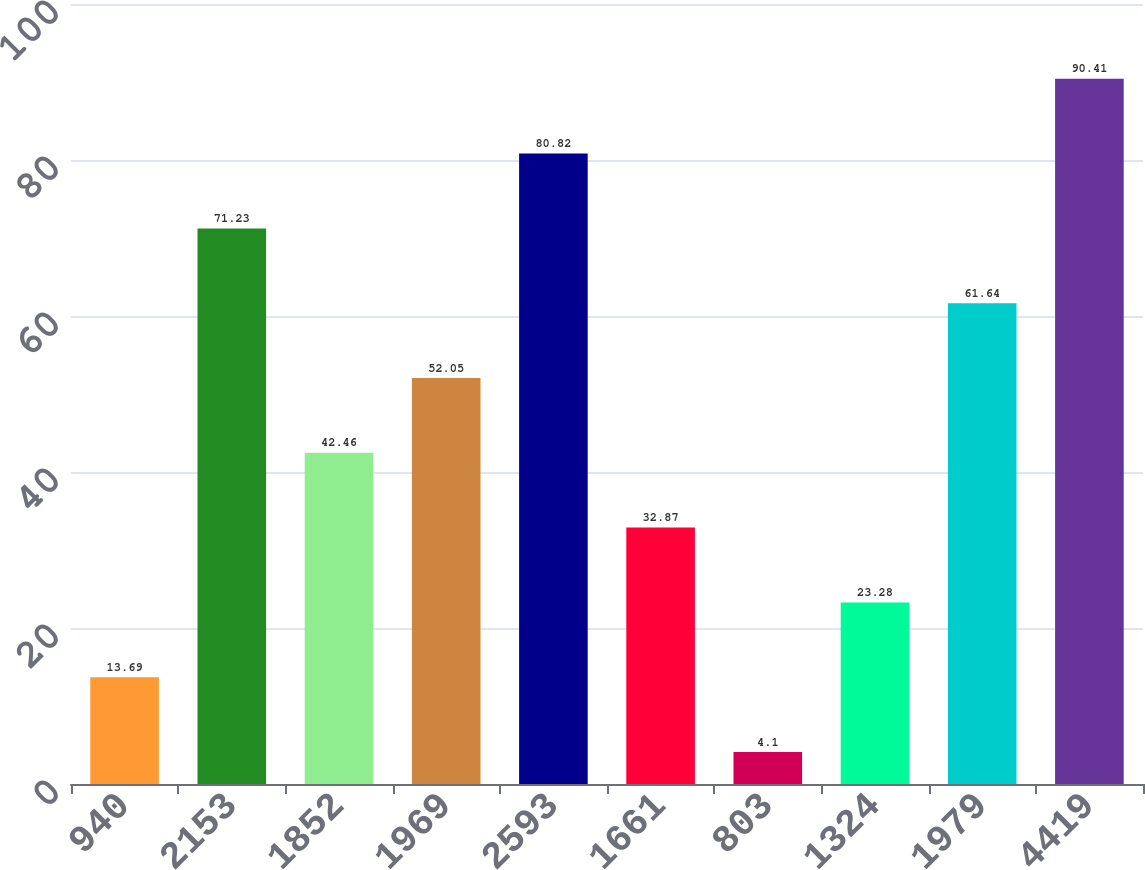Convert chart. <chart><loc_0><loc_0><loc_500><loc_500><bar_chart><fcel>940<fcel>2153<fcel>1852<fcel>1969<fcel>2593<fcel>1661<fcel>803<fcel>1324<fcel>1979<fcel>4419<nl><fcel>13.69<fcel>71.23<fcel>42.46<fcel>52.05<fcel>80.82<fcel>32.87<fcel>4.1<fcel>23.28<fcel>61.64<fcel>90.41<nl></chart> 